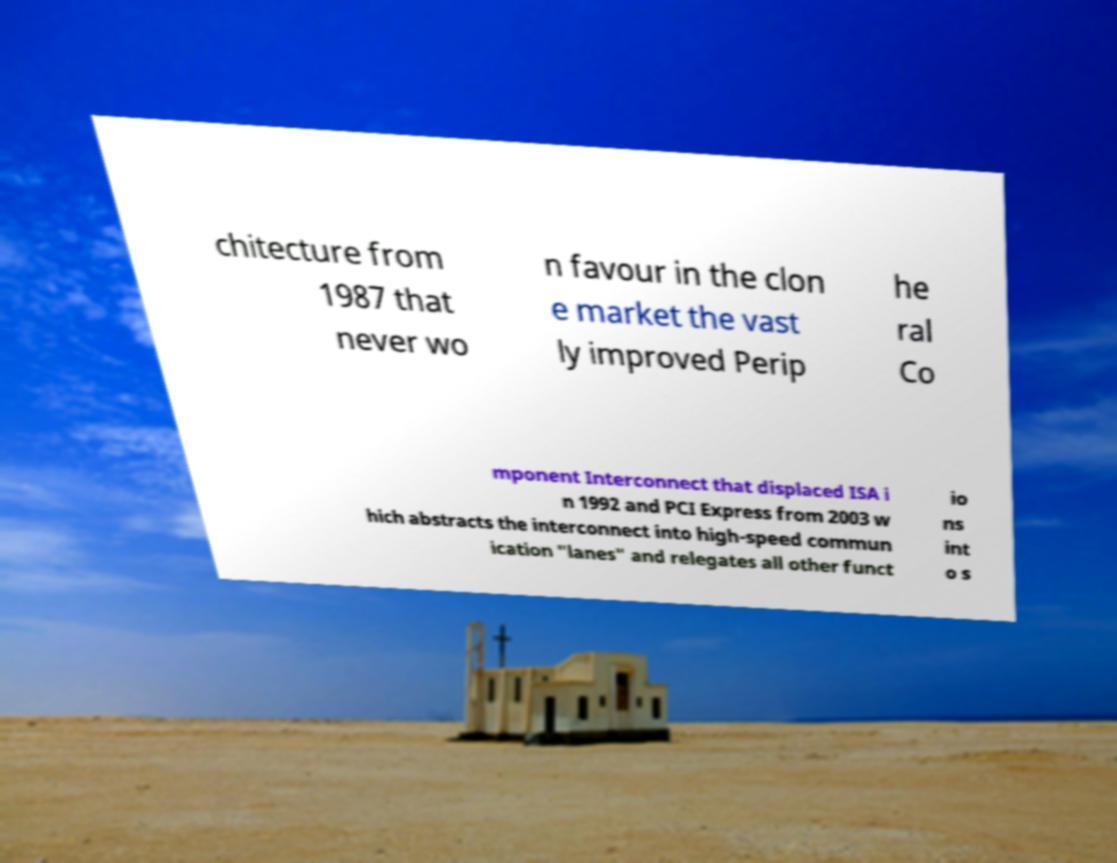There's text embedded in this image that I need extracted. Can you transcribe it verbatim? chitecture from 1987 that never wo n favour in the clon e market the vast ly improved Perip he ral Co mponent Interconnect that displaced ISA i n 1992 and PCI Express from 2003 w hich abstracts the interconnect into high-speed commun ication "lanes" and relegates all other funct io ns int o s 